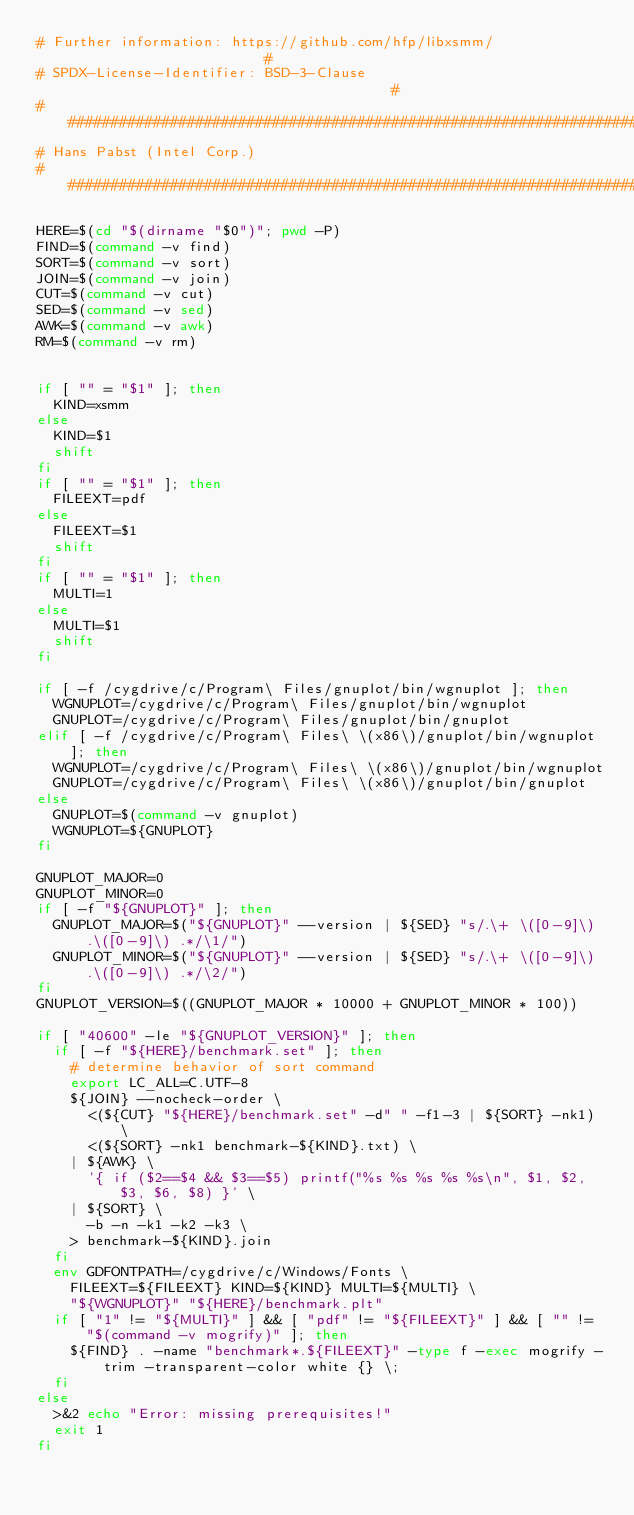<code> <loc_0><loc_0><loc_500><loc_500><_Bash_># Further information: https://github.com/hfp/libxsmm/                        #
# SPDX-License-Identifier: BSD-3-Clause                                       #
###############################################################################
# Hans Pabst (Intel Corp.)
###############################################################################

HERE=$(cd "$(dirname "$0")"; pwd -P)
FIND=$(command -v find)
SORT=$(command -v sort)
JOIN=$(command -v join)
CUT=$(command -v cut)
SED=$(command -v sed)
AWK=$(command -v awk)
RM=$(command -v rm)


if [ "" = "$1" ]; then
  KIND=xsmm
else
  KIND=$1
  shift
fi
if [ "" = "$1" ]; then
  FILEEXT=pdf
else
  FILEEXT=$1
  shift
fi
if [ "" = "$1" ]; then
  MULTI=1
else
  MULTI=$1
  shift
fi

if [ -f /cygdrive/c/Program\ Files/gnuplot/bin/wgnuplot ]; then
  WGNUPLOT=/cygdrive/c/Program\ Files/gnuplot/bin/wgnuplot
  GNUPLOT=/cygdrive/c/Program\ Files/gnuplot/bin/gnuplot
elif [ -f /cygdrive/c/Program\ Files\ \(x86\)/gnuplot/bin/wgnuplot ]; then
  WGNUPLOT=/cygdrive/c/Program\ Files\ \(x86\)/gnuplot/bin/wgnuplot
  GNUPLOT=/cygdrive/c/Program\ Files\ \(x86\)/gnuplot/bin/gnuplot
else
  GNUPLOT=$(command -v gnuplot)
  WGNUPLOT=${GNUPLOT}
fi

GNUPLOT_MAJOR=0
GNUPLOT_MINOR=0
if [ -f "${GNUPLOT}" ]; then
  GNUPLOT_MAJOR=$("${GNUPLOT}" --version | ${SED} "s/.\+ \([0-9]\).\([0-9]\) .*/\1/")
  GNUPLOT_MINOR=$("${GNUPLOT}" --version | ${SED} "s/.\+ \([0-9]\).\([0-9]\) .*/\2/")
fi
GNUPLOT_VERSION=$((GNUPLOT_MAJOR * 10000 + GNUPLOT_MINOR * 100))

if [ "40600" -le "${GNUPLOT_VERSION}" ]; then
  if [ -f "${HERE}/benchmark.set" ]; then
    # determine behavior of sort command
    export LC_ALL=C.UTF-8
    ${JOIN} --nocheck-order \
      <(${CUT} "${HERE}/benchmark.set" -d" " -f1-3 | ${SORT} -nk1) \
      <(${SORT} -nk1 benchmark-${KIND}.txt) \
    | ${AWK} \
      '{ if ($2==$4 && $3==$5) printf("%s %s %s %s %s\n", $1, $2, $3, $6, $8) }' \
    | ${SORT} \
      -b -n -k1 -k2 -k3 \
    > benchmark-${KIND}.join
  fi
  env GDFONTPATH=/cygdrive/c/Windows/Fonts \
    FILEEXT=${FILEEXT} KIND=${KIND} MULTI=${MULTI} \
    "${WGNUPLOT}" "${HERE}/benchmark.plt"
  if [ "1" != "${MULTI}" ] && [ "pdf" != "${FILEEXT}" ] && [ "" != "$(command -v mogrify)" ]; then
    ${FIND} . -name "benchmark*.${FILEEXT}" -type f -exec mogrify -trim -transparent-color white {} \;
  fi
else
  >&2 echo "Error: missing prerequisites!"
  exit 1
fi

</code> 